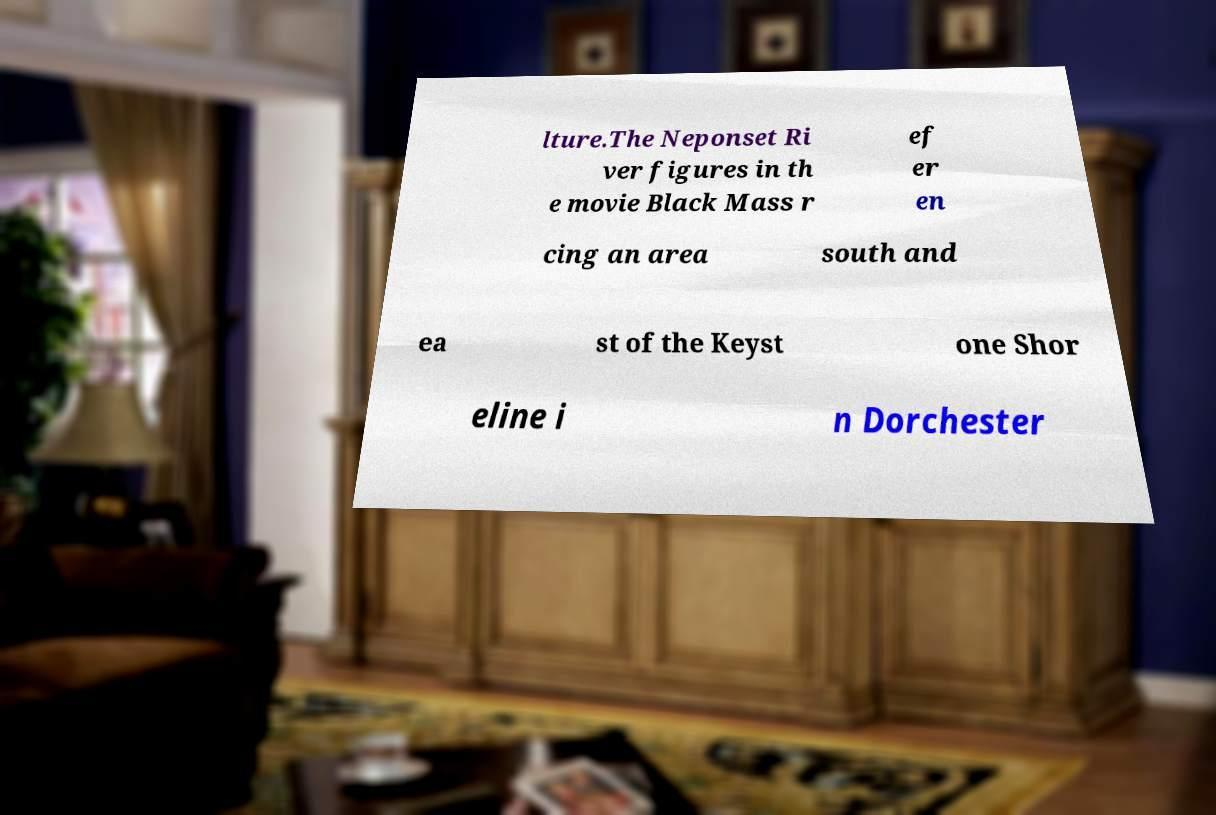Please read and relay the text visible in this image. What does it say? lture.The Neponset Ri ver figures in th e movie Black Mass r ef er en cing an area south and ea st of the Keyst one Shor eline i n Dorchester 